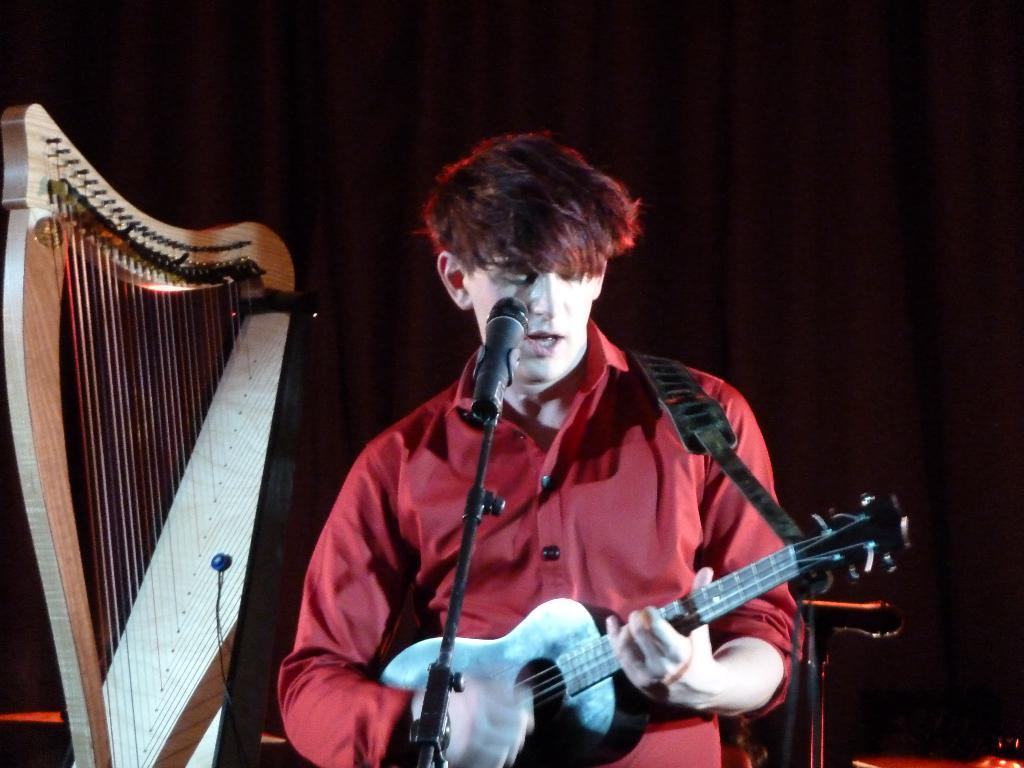What is the man in the image doing? The man is playing a guitar in the image. What object is present in the image that is typically used for amplifying sound? There is a microphone in the image. How many icicles can be seen hanging from the guitar in the image? There are no icicles present in the image, as it features a man playing a guitar and a microphone. 